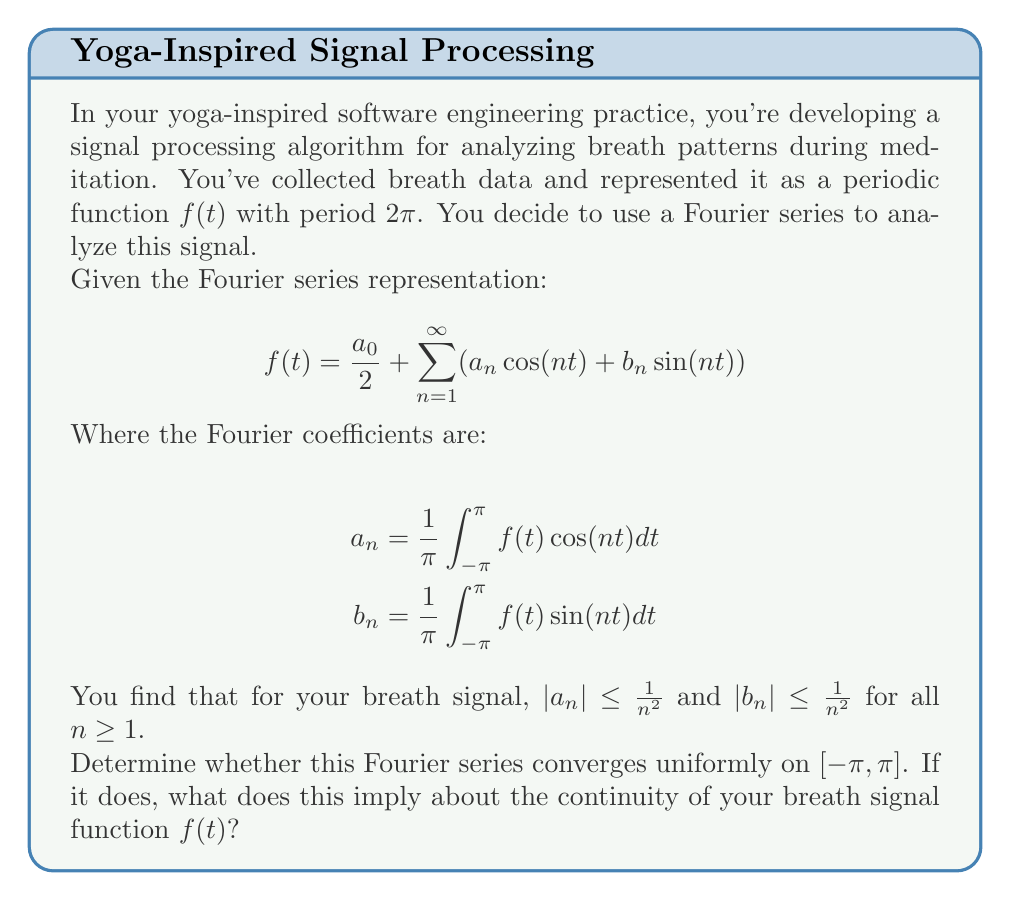Show me your answer to this math problem. Let's approach this step-by-step:

1) First, recall the Weierstrass M-test for uniform convergence. It states that if we have a series $\sum_{n=1}^{\infty} f_n(x)$ and there exists a sequence of constants $M_n$ such that $|f_n(x)| \leq M_n$ for all $x$ in the domain and all $n$, and if $\sum_{n=1}^{\infty} M_n$ converges, then the original series converges uniformly.

2) In our case, we need to consider the series:

   $$\sum_{n=1}^{\infty} (a_n \cos(nt) + b_n \sin(nt))$$

3) We're given that $|a_n| \leq \frac{1}{n^2}$ and $|b_n| \leq \frac{1}{n^2}$ for all $n \geq 1$.

4) Note that $|\cos(nt)| \leq 1$ and $|\sin(nt)| \leq 1$ for all $t$ and $n$.

5) Therefore, we can say:

   $|a_n \cos(nt) + b_n \sin(nt)| \leq |a_n| + |b_n| \leq \frac{1}{n^2} + \frac{1}{n^2} = \frac{2}{n^2}$

6) Now, we can apply the Weierstrass M-test with $M_n = \frac{2}{n^2}$.

7) We need to check if $\sum_{n=1}^{\infty} \frac{2}{n^2}$ converges. This is a p-series with $p=2$, which is known to converge (in fact, it converges to $\frac{\pi^2}{3}$).

8) Since $\sum_{n=1}^{\infty} M_n$ converges, by the Weierstrass M-test, our original Fourier series converges uniformly on $[-\pi, \pi]$.

9) Uniform convergence of the Fourier series implies that the function $f(t)$ is continuous on $[-\pi, \pi]$. This is because the partial sums of the Fourier series are continuous functions, and uniform convergence preserves continuity in the limit.

Therefore, we can conclude that the Fourier series converges uniformly, and the breath signal function $f(t)$ is continuous on $[-\pi, \pi]$.
Answer: The Fourier series converges uniformly on $[-\pi, \pi]$, implying $f(t)$ is continuous on this interval. 